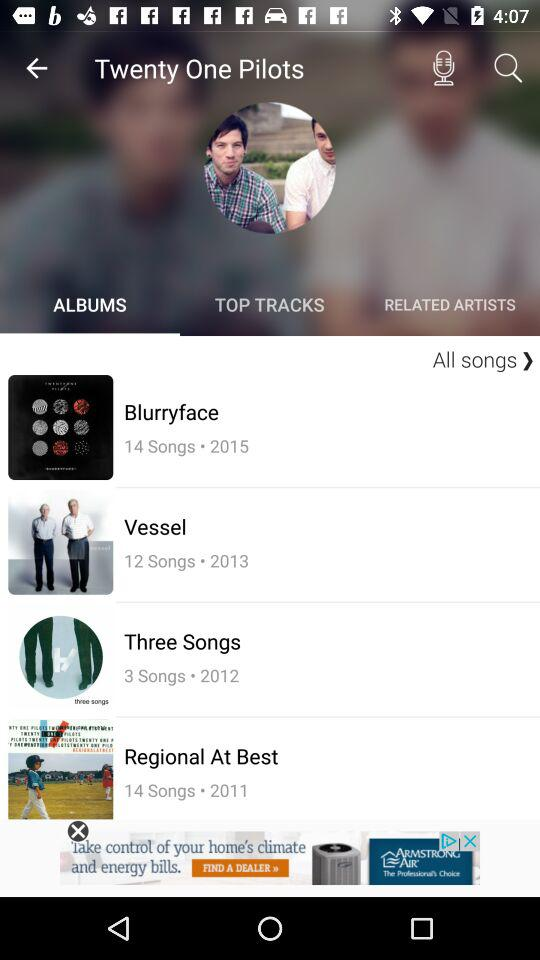What was the release year of "Vessel"? The release year of "Vessel" was 2013. 